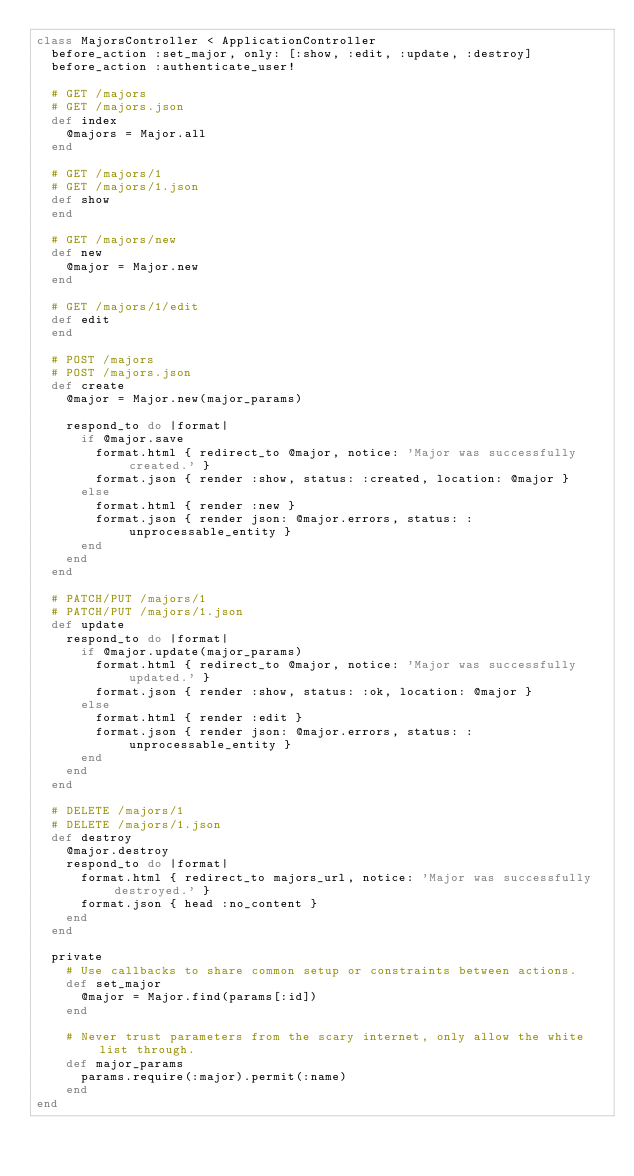<code> <loc_0><loc_0><loc_500><loc_500><_Ruby_>class MajorsController < ApplicationController
  before_action :set_major, only: [:show, :edit, :update, :destroy]
  before_action :authenticate_user!

  # GET /majors
  # GET /majors.json
  def index
    @majors = Major.all
  end

  # GET /majors/1
  # GET /majors/1.json
  def show
  end

  # GET /majors/new
  def new
    @major = Major.new
  end

  # GET /majors/1/edit
  def edit
  end

  # POST /majors
  # POST /majors.json
  def create
    @major = Major.new(major_params)

    respond_to do |format|
      if @major.save
        format.html { redirect_to @major, notice: 'Major was successfully created.' }
        format.json { render :show, status: :created, location: @major }
      else
        format.html { render :new }
        format.json { render json: @major.errors, status: :unprocessable_entity }
      end
    end
  end

  # PATCH/PUT /majors/1
  # PATCH/PUT /majors/1.json
  def update
    respond_to do |format|
      if @major.update(major_params)
        format.html { redirect_to @major, notice: 'Major was successfully updated.' }
        format.json { render :show, status: :ok, location: @major }
      else
        format.html { render :edit }
        format.json { render json: @major.errors, status: :unprocessable_entity }
      end
    end
  end

  # DELETE /majors/1
  # DELETE /majors/1.json
  def destroy
    @major.destroy
    respond_to do |format|
      format.html { redirect_to majors_url, notice: 'Major was successfully destroyed.' }
      format.json { head :no_content }
    end
  end

  private
    # Use callbacks to share common setup or constraints between actions.
    def set_major
      @major = Major.find(params[:id])
    end

    # Never trust parameters from the scary internet, only allow the white list through.
    def major_params
      params.require(:major).permit(:name)
    end
end
</code> 